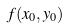<formula> <loc_0><loc_0><loc_500><loc_500>f ( x _ { 0 } , y _ { 0 } )</formula> 